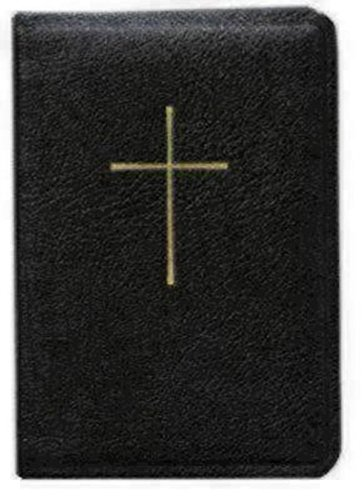What is the title of this book? The title as provided on the cover is not visible in this image. To determine the title, one would typically look for any text on the cover or spine, or open the book to view the title page. 